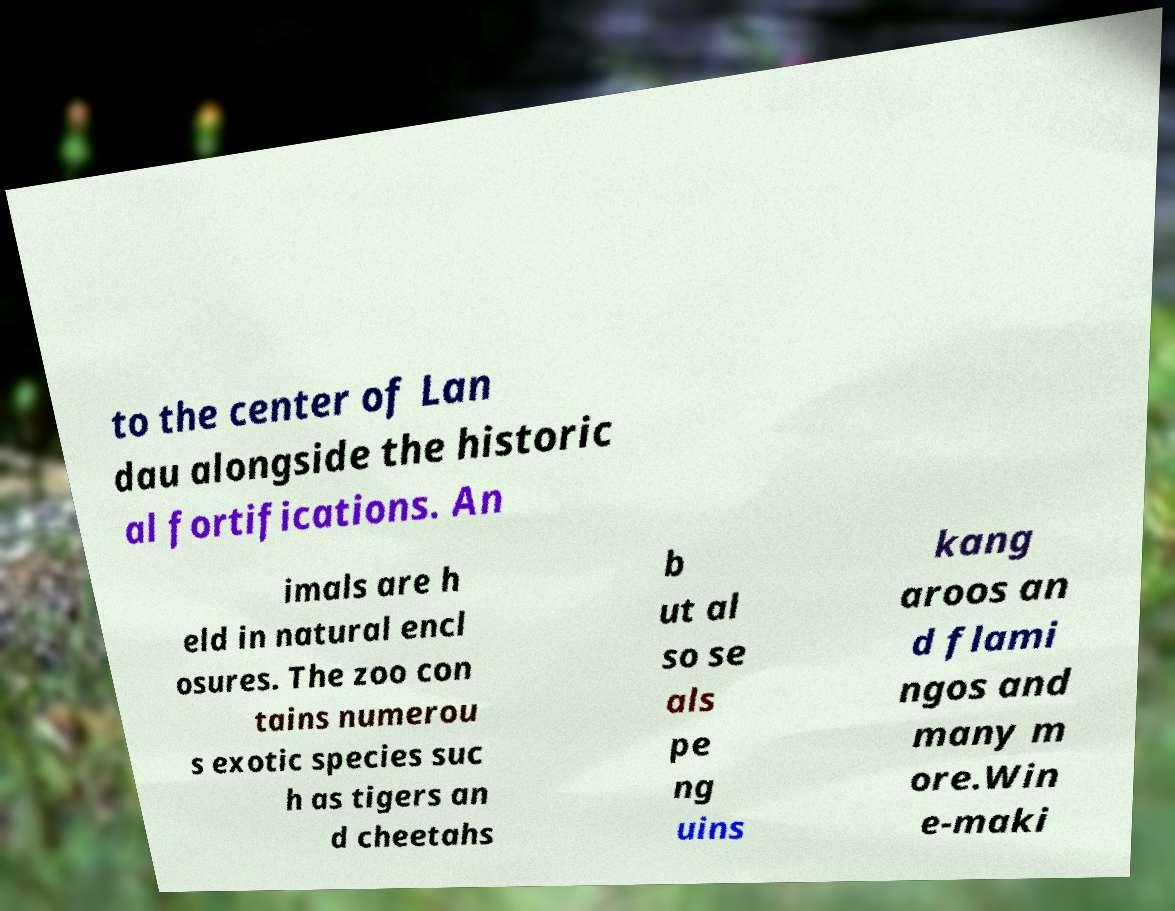What messages or text are displayed in this image? I need them in a readable, typed format. to the center of Lan dau alongside the historic al fortifications. An imals are h eld in natural encl osures. The zoo con tains numerou s exotic species suc h as tigers an d cheetahs b ut al so se als pe ng uins kang aroos an d flami ngos and many m ore.Win e-maki 